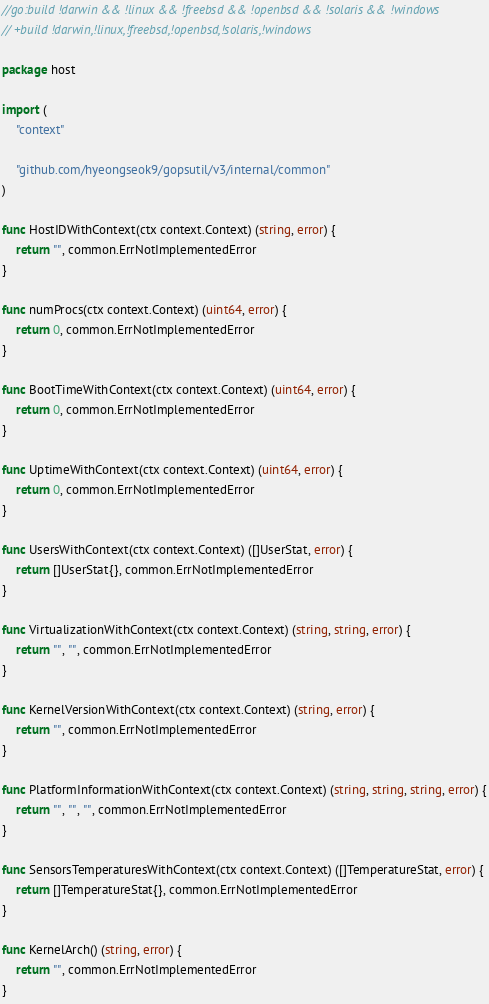<code> <loc_0><loc_0><loc_500><loc_500><_Go_>//go:build !darwin && !linux && !freebsd && !openbsd && !solaris && !windows
// +build !darwin,!linux,!freebsd,!openbsd,!solaris,!windows

package host

import (
	"context"

	"github.com/hyeongseok9/gopsutil/v3/internal/common"
)

func HostIDWithContext(ctx context.Context) (string, error) {
	return "", common.ErrNotImplementedError
}

func numProcs(ctx context.Context) (uint64, error) {
	return 0, common.ErrNotImplementedError
}

func BootTimeWithContext(ctx context.Context) (uint64, error) {
	return 0, common.ErrNotImplementedError
}

func UptimeWithContext(ctx context.Context) (uint64, error) {
	return 0, common.ErrNotImplementedError
}

func UsersWithContext(ctx context.Context) ([]UserStat, error) {
	return []UserStat{}, common.ErrNotImplementedError
}

func VirtualizationWithContext(ctx context.Context) (string, string, error) {
	return "", "", common.ErrNotImplementedError
}

func KernelVersionWithContext(ctx context.Context) (string, error) {
	return "", common.ErrNotImplementedError
}

func PlatformInformationWithContext(ctx context.Context) (string, string, string, error) {
	return "", "", "", common.ErrNotImplementedError
}

func SensorsTemperaturesWithContext(ctx context.Context) ([]TemperatureStat, error) {
	return []TemperatureStat{}, common.ErrNotImplementedError
}

func KernelArch() (string, error) {
	return "", common.ErrNotImplementedError
}
</code> 